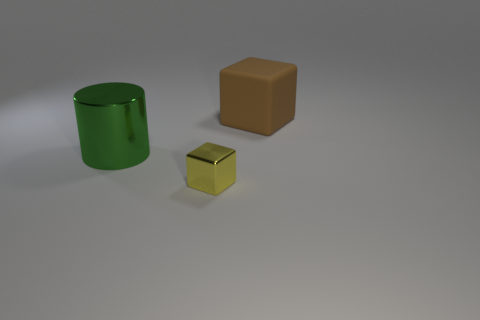Is there anything else that has the same material as the big brown object?
Make the answer very short. No. What number of green cylinders have the same size as the rubber block?
Ensure brevity in your answer.  1. There is a thing that is on the right side of the small yellow shiny cube; is its shape the same as the small yellow shiny object?
Offer a terse response. Yes. Is the number of yellow shiny things on the left side of the big rubber object less than the number of things?
Offer a terse response. Yes. Do the tiny object and the thing that is behind the green shiny cylinder have the same shape?
Provide a succinct answer. Yes. Is there a block that has the same material as the cylinder?
Offer a very short reply. Yes. Are there any objects left of the big thing that is to the right of the cube left of the large cube?
Provide a succinct answer. Yes. How many other objects are there of the same shape as the brown matte object?
Give a very brief answer. 1. There is a block that is behind the object in front of the thing that is to the left of the metallic cube; what is its color?
Offer a very short reply. Brown. How many big cyan rubber cubes are there?
Ensure brevity in your answer.  0. 